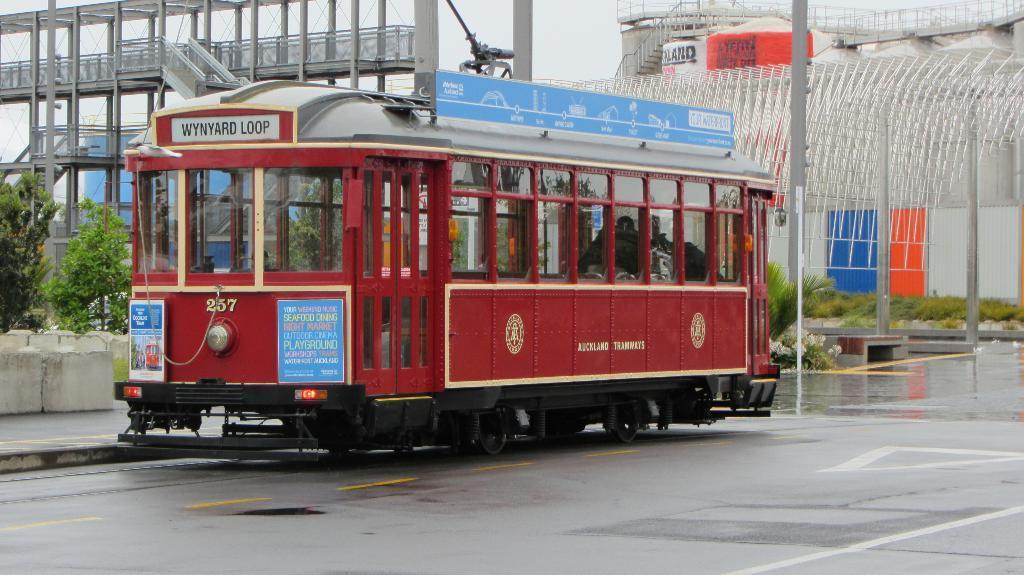In one or two sentences, can you explain what this image depicts? In this picture we can see a vehicle on the road, grass, trees, posters, some objects and in the background we can see the sky. 